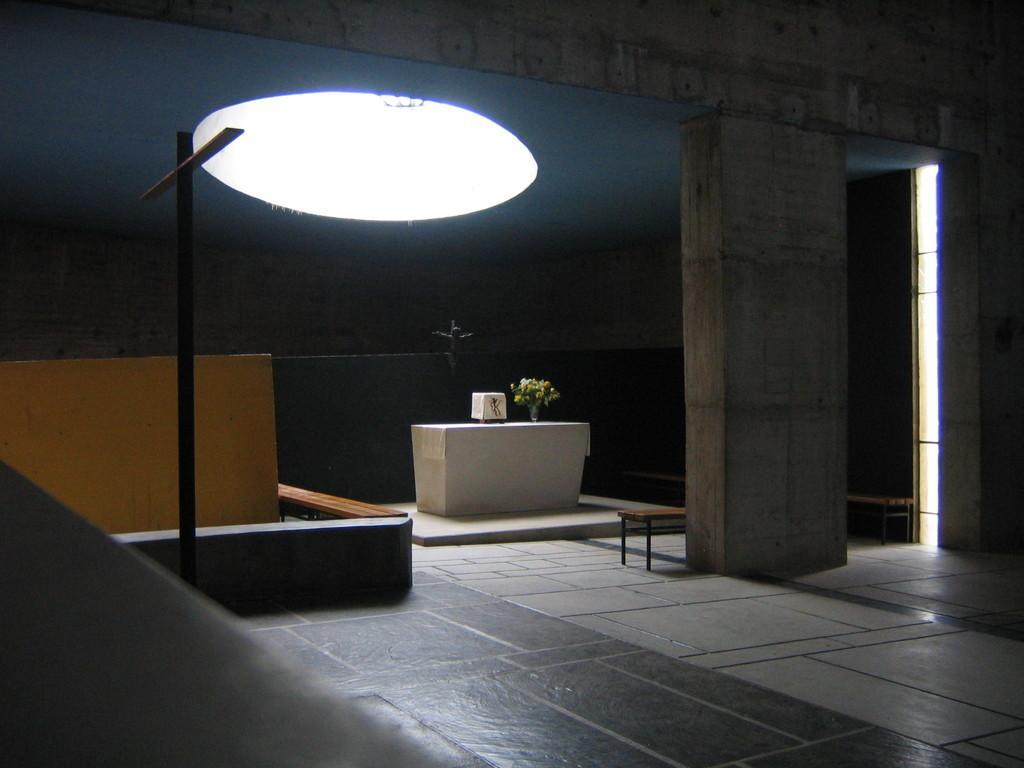Could you give a brief overview of what you see in this image? In this image there is a desk, there are objects on the desk, there are benches, there is a pillar, there is ground towards the bottom of the image, there is an object towards the left of the image, there is a board, there is a light. 